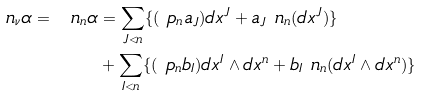Convert formula to latex. <formula><loc_0><loc_0><loc_500><loc_500>\ n _ { \nu } \alpha = \ n _ { n } \alpha & = \sum _ { J < n } \{ ( \ p _ { n } a _ { J } ) d x ^ { J } + a _ { J } \ n _ { n } ( d x ^ { J } ) \} \\ & + \sum _ { I < n } \{ ( \ p _ { n } b _ { I } ) d x ^ { I } \wedge d x ^ { n } + b _ { I } \ n _ { n } ( d x ^ { I } \wedge d x ^ { n } ) \}</formula> 